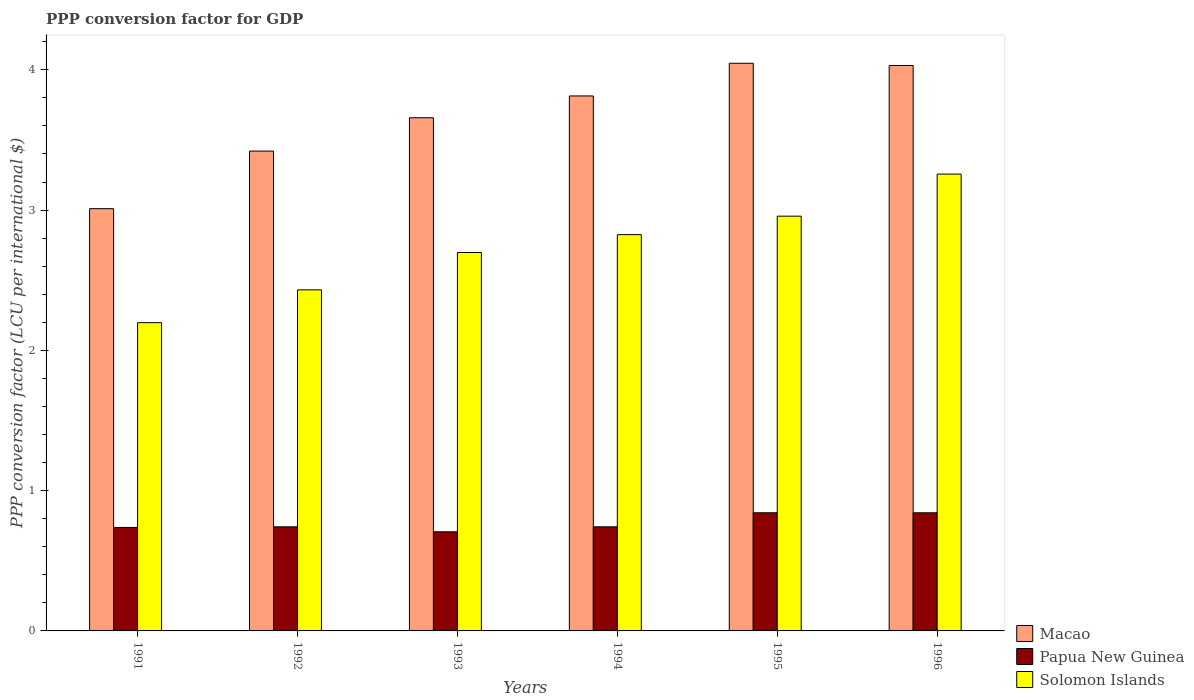How many different coloured bars are there?
Make the answer very short. 3. How many groups of bars are there?
Your answer should be very brief. 6. Are the number of bars per tick equal to the number of legend labels?
Give a very brief answer. Yes. Are the number of bars on each tick of the X-axis equal?
Ensure brevity in your answer.  Yes. How many bars are there on the 5th tick from the left?
Provide a succinct answer. 3. In how many cases, is the number of bars for a given year not equal to the number of legend labels?
Keep it short and to the point. 0. What is the PPP conversion factor for GDP in Macao in 1996?
Offer a very short reply. 4.03. Across all years, what is the maximum PPP conversion factor for GDP in Solomon Islands?
Provide a succinct answer. 3.26. Across all years, what is the minimum PPP conversion factor for GDP in Macao?
Make the answer very short. 3.01. What is the total PPP conversion factor for GDP in Solomon Islands in the graph?
Your answer should be very brief. 16.37. What is the difference between the PPP conversion factor for GDP in Papua New Guinea in 1993 and that in 1995?
Your answer should be compact. -0.14. What is the difference between the PPP conversion factor for GDP in Solomon Islands in 1992 and the PPP conversion factor for GDP in Papua New Guinea in 1996?
Ensure brevity in your answer.  1.59. What is the average PPP conversion factor for GDP in Solomon Islands per year?
Ensure brevity in your answer.  2.73. In the year 1992, what is the difference between the PPP conversion factor for GDP in Solomon Islands and PPP conversion factor for GDP in Papua New Guinea?
Provide a succinct answer. 1.69. What is the ratio of the PPP conversion factor for GDP in Papua New Guinea in 1992 to that in 1994?
Ensure brevity in your answer.  1. Is the PPP conversion factor for GDP in Papua New Guinea in 1995 less than that in 1996?
Your answer should be very brief. No. Is the difference between the PPP conversion factor for GDP in Solomon Islands in 1992 and 1993 greater than the difference between the PPP conversion factor for GDP in Papua New Guinea in 1992 and 1993?
Provide a short and direct response. No. What is the difference between the highest and the second highest PPP conversion factor for GDP in Papua New Guinea?
Offer a terse response. 0. What is the difference between the highest and the lowest PPP conversion factor for GDP in Papua New Guinea?
Your answer should be compact. 0.14. What does the 3rd bar from the left in 1994 represents?
Make the answer very short. Solomon Islands. What does the 2nd bar from the right in 1991 represents?
Give a very brief answer. Papua New Guinea. Is it the case that in every year, the sum of the PPP conversion factor for GDP in Solomon Islands and PPP conversion factor for GDP in Papua New Guinea is greater than the PPP conversion factor for GDP in Macao?
Your response must be concise. No. How many bars are there?
Give a very brief answer. 18. Are all the bars in the graph horizontal?
Your answer should be very brief. No. What is the difference between two consecutive major ticks on the Y-axis?
Keep it short and to the point. 1. Where does the legend appear in the graph?
Ensure brevity in your answer.  Bottom right. How many legend labels are there?
Ensure brevity in your answer.  3. How are the legend labels stacked?
Keep it short and to the point. Vertical. What is the title of the graph?
Ensure brevity in your answer.  PPP conversion factor for GDP. Does "Virgin Islands" appear as one of the legend labels in the graph?
Ensure brevity in your answer.  No. What is the label or title of the X-axis?
Ensure brevity in your answer.  Years. What is the label or title of the Y-axis?
Your response must be concise. PPP conversion factor (LCU per international $). What is the PPP conversion factor (LCU per international $) of Macao in 1991?
Your response must be concise. 3.01. What is the PPP conversion factor (LCU per international $) of Papua New Guinea in 1991?
Your answer should be compact. 0.74. What is the PPP conversion factor (LCU per international $) in Solomon Islands in 1991?
Offer a very short reply. 2.2. What is the PPP conversion factor (LCU per international $) of Macao in 1992?
Give a very brief answer. 3.42. What is the PPP conversion factor (LCU per international $) of Papua New Guinea in 1992?
Your response must be concise. 0.74. What is the PPP conversion factor (LCU per international $) in Solomon Islands in 1992?
Offer a very short reply. 2.43. What is the PPP conversion factor (LCU per international $) of Macao in 1993?
Your response must be concise. 3.66. What is the PPP conversion factor (LCU per international $) of Papua New Guinea in 1993?
Provide a succinct answer. 0.71. What is the PPP conversion factor (LCU per international $) of Solomon Islands in 1993?
Make the answer very short. 2.7. What is the PPP conversion factor (LCU per international $) of Macao in 1994?
Ensure brevity in your answer.  3.81. What is the PPP conversion factor (LCU per international $) in Papua New Guinea in 1994?
Provide a succinct answer. 0.74. What is the PPP conversion factor (LCU per international $) in Solomon Islands in 1994?
Your answer should be very brief. 2.82. What is the PPP conversion factor (LCU per international $) of Macao in 1995?
Keep it short and to the point. 4.05. What is the PPP conversion factor (LCU per international $) of Papua New Guinea in 1995?
Your answer should be very brief. 0.84. What is the PPP conversion factor (LCU per international $) of Solomon Islands in 1995?
Offer a terse response. 2.96. What is the PPP conversion factor (LCU per international $) of Macao in 1996?
Your response must be concise. 4.03. What is the PPP conversion factor (LCU per international $) in Papua New Guinea in 1996?
Ensure brevity in your answer.  0.84. What is the PPP conversion factor (LCU per international $) of Solomon Islands in 1996?
Make the answer very short. 3.26. Across all years, what is the maximum PPP conversion factor (LCU per international $) of Macao?
Your answer should be compact. 4.05. Across all years, what is the maximum PPP conversion factor (LCU per international $) in Papua New Guinea?
Ensure brevity in your answer.  0.84. Across all years, what is the maximum PPP conversion factor (LCU per international $) in Solomon Islands?
Give a very brief answer. 3.26. Across all years, what is the minimum PPP conversion factor (LCU per international $) of Macao?
Ensure brevity in your answer.  3.01. Across all years, what is the minimum PPP conversion factor (LCU per international $) in Papua New Guinea?
Your response must be concise. 0.71. Across all years, what is the minimum PPP conversion factor (LCU per international $) of Solomon Islands?
Give a very brief answer. 2.2. What is the total PPP conversion factor (LCU per international $) in Macao in the graph?
Your response must be concise. 21.98. What is the total PPP conversion factor (LCU per international $) in Papua New Guinea in the graph?
Offer a terse response. 4.61. What is the total PPP conversion factor (LCU per international $) of Solomon Islands in the graph?
Make the answer very short. 16.36. What is the difference between the PPP conversion factor (LCU per international $) in Macao in 1991 and that in 1992?
Offer a very short reply. -0.41. What is the difference between the PPP conversion factor (LCU per international $) in Papua New Guinea in 1991 and that in 1992?
Offer a terse response. -0. What is the difference between the PPP conversion factor (LCU per international $) in Solomon Islands in 1991 and that in 1992?
Provide a short and direct response. -0.23. What is the difference between the PPP conversion factor (LCU per international $) in Macao in 1991 and that in 1993?
Offer a terse response. -0.65. What is the difference between the PPP conversion factor (LCU per international $) in Papua New Guinea in 1991 and that in 1993?
Provide a short and direct response. 0.03. What is the difference between the PPP conversion factor (LCU per international $) in Solomon Islands in 1991 and that in 1993?
Your answer should be very brief. -0.5. What is the difference between the PPP conversion factor (LCU per international $) in Macao in 1991 and that in 1994?
Your answer should be compact. -0.8. What is the difference between the PPP conversion factor (LCU per international $) of Papua New Guinea in 1991 and that in 1994?
Provide a succinct answer. -0. What is the difference between the PPP conversion factor (LCU per international $) of Solomon Islands in 1991 and that in 1994?
Keep it short and to the point. -0.63. What is the difference between the PPP conversion factor (LCU per international $) of Macao in 1991 and that in 1995?
Make the answer very short. -1.04. What is the difference between the PPP conversion factor (LCU per international $) of Papua New Guinea in 1991 and that in 1995?
Your answer should be compact. -0.1. What is the difference between the PPP conversion factor (LCU per international $) of Solomon Islands in 1991 and that in 1995?
Provide a short and direct response. -0.76. What is the difference between the PPP conversion factor (LCU per international $) of Macao in 1991 and that in 1996?
Ensure brevity in your answer.  -1.02. What is the difference between the PPP conversion factor (LCU per international $) of Papua New Guinea in 1991 and that in 1996?
Give a very brief answer. -0.1. What is the difference between the PPP conversion factor (LCU per international $) of Solomon Islands in 1991 and that in 1996?
Make the answer very short. -1.06. What is the difference between the PPP conversion factor (LCU per international $) of Macao in 1992 and that in 1993?
Make the answer very short. -0.24. What is the difference between the PPP conversion factor (LCU per international $) in Papua New Guinea in 1992 and that in 1993?
Offer a terse response. 0.04. What is the difference between the PPP conversion factor (LCU per international $) in Solomon Islands in 1992 and that in 1993?
Your answer should be very brief. -0.27. What is the difference between the PPP conversion factor (LCU per international $) of Macao in 1992 and that in 1994?
Keep it short and to the point. -0.39. What is the difference between the PPP conversion factor (LCU per international $) in Papua New Guinea in 1992 and that in 1994?
Provide a short and direct response. -0. What is the difference between the PPP conversion factor (LCU per international $) in Solomon Islands in 1992 and that in 1994?
Your response must be concise. -0.39. What is the difference between the PPP conversion factor (LCU per international $) of Macao in 1992 and that in 1995?
Give a very brief answer. -0.63. What is the difference between the PPP conversion factor (LCU per international $) of Papua New Guinea in 1992 and that in 1995?
Offer a terse response. -0.1. What is the difference between the PPP conversion factor (LCU per international $) in Solomon Islands in 1992 and that in 1995?
Offer a very short reply. -0.53. What is the difference between the PPP conversion factor (LCU per international $) in Macao in 1992 and that in 1996?
Provide a short and direct response. -0.61. What is the difference between the PPP conversion factor (LCU per international $) of Papua New Guinea in 1992 and that in 1996?
Keep it short and to the point. -0.1. What is the difference between the PPP conversion factor (LCU per international $) of Solomon Islands in 1992 and that in 1996?
Give a very brief answer. -0.83. What is the difference between the PPP conversion factor (LCU per international $) in Macao in 1993 and that in 1994?
Your response must be concise. -0.16. What is the difference between the PPP conversion factor (LCU per international $) of Papua New Guinea in 1993 and that in 1994?
Your answer should be very brief. -0.04. What is the difference between the PPP conversion factor (LCU per international $) of Solomon Islands in 1993 and that in 1994?
Provide a succinct answer. -0.13. What is the difference between the PPP conversion factor (LCU per international $) in Macao in 1993 and that in 1995?
Your answer should be very brief. -0.39. What is the difference between the PPP conversion factor (LCU per international $) in Papua New Guinea in 1993 and that in 1995?
Your answer should be compact. -0.14. What is the difference between the PPP conversion factor (LCU per international $) in Solomon Islands in 1993 and that in 1995?
Your response must be concise. -0.26. What is the difference between the PPP conversion factor (LCU per international $) of Macao in 1993 and that in 1996?
Offer a terse response. -0.37. What is the difference between the PPP conversion factor (LCU per international $) in Papua New Guinea in 1993 and that in 1996?
Give a very brief answer. -0.14. What is the difference between the PPP conversion factor (LCU per international $) in Solomon Islands in 1993 and that in 1996?
Offer a terse response. -0.56. What is the difference between the PPP conversion factor (LCU per international $) in Macao in 1994 and that in 1995?
Your answer should be very brief. -0.23. What is the difference between the PPP conversion factor (LCU per international $) of Papua New Guinea in 1994 and that in 1995?
Provide a short and direct response. -0.1. What is the difference between the PPP conversion factor (LCU per international $) of Solomon Islands in 1994 and that in 1995?
Give a very brief answer. -0.13. What is the difference between the PPP conversion factor (LCU per international $) in Macao in 1994 and that in 1996?
Keep it short and to the point. -0.22. What is the difference between the PPP conversion factor (LCU per international $) in Solomon Islands in 1994 and that in 1996?
Your answer should be very brief. -0.43. What is the difference between the PPP conversion factor (LCU per international $) of Macao in 1995 and that in 1996?
Offer a terse response. 0.02. What is the difference between the PPP conversion factor (LCU per international $) of Papua New Guinea in 1995 and that in 1996?
Provide a short and direct response. 0. What is the difference between the PPP conversion factor (LCU per international $) in Solomon Islands in 1995 and that in 1996?
Provide a succinct answer. -0.3. What is the difference between the PPP conversion factor (LCU per international $) in Macao in 1991 and the PPP conversion factor (LCU per international $) in Papua New Guinea in 1992?
Your answer should be very brief. 2.27. What is the difference between the PPP conversion factor (LCU per international $) in Macao in 1991 and the PPP conversion factor (LCU per international $) in Solomon Islands in 1992?
Provide a succinct answer. 0.58. What is the difference between the PPP conversion factor (LCU per international $) of Papua New Guinea in 1991 and the PPP conversion factor (LCU per international $) of Solomon Islands in 1992?
Give a very brief answer. -1.69. What is the difference between the PPP conversion factor (LCU per international $) in Macao in 1991 and the PPP conversion factor (LCU per international $) in Papua New Guinea in 1993?
Provide a short and direct response. 2.3. What is the difference between the PPP conversion factor (LCU per international $) in Macao in 1991 and the PPP conversion factor (LCU per international $) in Solomon Islands in 1993?
Make the answer very short. 0.31. What is the difference between the PPP conversion factor (LCU per international $) of Papua New Guinea in 1991 and the PPP conversion factor (LCU per international $) of Solomon Islands in 1993?
Offer a terse response. -1.96. What is the difference between the PPP conversion factor (LCU per international $) in Macao in 1991 and the PPP conversion factor (LCU per international $) in Papua New Guinea in 1994?
Give a very brief answer. 2.27. What is the difference between the PPP conversion factor (LCU per international $) of Macao in 1991 and the PPP conversion factor (LCU per international $) of Solomon Islands in 1994?
Ensure brevity in your answer.  0.18. What is the difference between the PPP conversion factor (LCU per international $) of Papua New Guinea in 1991 and the PPP conversion factor (LCU per international $) of Solomon Islands in 1994?
Keep it short and to the point. -2.09. What is the difference between the PPP conversion factor (LCU per international $) of Macao in 1991 and the PPP conversion factor (LCU per international $) of Papua New Guinea in 1995?
Keep it short and to the point. 2.17. What is the difference between the PPP conversion factor (LCU per international $) of Macao in 1991 and the PPP conversion factor (LCU per international $) of Solomon Islands in 1995?
Provide a succinct answer. 0.05. What is the difference between the PPP conversion factor (LCU per international $) in Papua New Guinea in 1991 and the PPP conversion factor (LCU per international $) in Solomon Islands in 1995?
Provide a succinct answer. -2.22. What is the difference between the PPP conversion factor (LCU per international $) of Macao in 1991 and the PPP conversion factor (LCU per international $) of Papua New Guinea in 1996?
Give a very brief answer. 2.17. What is the difference between the PPP conversion factor (LCU per international $) of Macao in 1991 and the PPP conversion factor (LCU per international $) of Solomon Islands in 1996?
Your response must be concise. -0.25. What is the difference between the PPP conversion factor (LCU per international $) of Papua New Guinea in 1991 and the PPP conversion factor (LCU per international $) of Solomon Islands in 1996?
Your answer should be compact. -2.52. What is the difference between the PPP conversion factor (LCU per international $) in Macao in 1992 and the PPP conversion factor (LCU per international $) in Papua New Guinea in 1993?
Offer a very short reply. 2.71. What is the difference between the PPP conversion factor (LCU per international $) in Macao in 1992 and the PPP conversion factor (LCU per international $) in Solomon Islands in 1993?
Ensure brevity in your answer.  0.72. What is the difference between the PPP conversion factor (LCU per international $) in Papua New Guinea in 1992 and the PPP conversion factor (LCU per international $) in Solomon Islands in 1993?
Make the answer very short. -1.96. What is the difference between the PPP conversion factor (LCU per international $) of Macao in 1992 and the PPP conversion factor (LCU per international $) of Papua New Guinea in 1994?
Provide a succinct answer. 2.68. What is the difference between the PPP conversion factor (LCU per international $) in Macao in 1992 and the PPP conversion factor (LCU per international $) in Solomon Islands in 1994?
Your answer should be very brief. 0.6. What is the difference between the PPP conversion factor (LCU per international $) of Papua New Guinea in 1992 and the PPP conversion factor (LCU per international $) of Solomon Islands in 1994?
Provide a short and direct response. -2.08. What is the difference between the PPP conversion factor (LCU per international $) in Macao in 1992 and the PPP conversion factor (LCU per international $) in Papua New Guinea in 1995?
Ensure brevity in your answer.  2.58. What is the difference between the PPP conversion factor (LCU per international $) in Macao in 1992 and the PPP conversion factor (LCU per international $) in Solomon Islands in 1995?
Offer a terse response. 0.46. What is the difference between the PPP conversion factor (LCU per international $) of Papua New Guinea in 1992 and the PPP conversion factor (LCU per international $) of Solomon Islands in 1995?
Your response must be concise. -2.21. What is the difference between the PPP conversion factor (LCU per international $) in Macao in 1992 and the PPP conversion factor (LCU per international $) in Papua New Guinea in 1996?
Provide a succinct answer. 2.58. What is the difference between the PPP conversion factor (LCU per international $) of Macao in 1992 and the PPP conversion factor (LCU per international $) of Solomon Islands in 1996?
Your answer should be very brief. 0.16. What is the difference between the PPP conversion factor (LCU per international $) of Papua New Guinea in 1992 and the PPP conversion factor (LCU per international $) of Solomon Islands in 1996?
Your answer should be compact. -2.51. What is the difference between the PPP conversion factor (LCU per international $) in Macao in 1993 and the PPP conversion factor (LCU per international $) in Papua New Guinea in 1994?
Offer a very short reply. 2.92. What is the difference between the PPP conversion factor (LCU per international $) in Macao in 1993 and the PPP conversion factor (LCU per international $) in Solomon Islands in 1994?
Your answer should be compact. 0.83. What is the difference between the PPP conversion factor (LCU per international $) in Papua New Guinea in 1993 and the PPP conversion factor (LCU per international $) in Solomon Islands in 1994?
Your answer should be compact. -2.12. What is the difference between the PPP conversion factor (LCU per international $) of Macao in 1993 and the PPP conversion factor (LCU per international $) of Papua New Guinea in 1995?
Keep it short and to the point. 2.82. What is the difference between the PPP conversion factor (LCU per international $) of Macao in 1993 and the PPP conversion factor (LCU per international $) of Solomon Islands in 1995?
Give a very brief answer. 0.7. What is the difference between the PPP conversion factor (LCU per international $) of Papua New Guinea in 1993 and the PPP conversion factor (LCU per international $) of Solomon Islands in 1995?
Offer a terse response. -2.25. What is the difference between the PPP conversion factor (LCU per international $) in Macao in 1993 and the PPP conversion factor (LCU per international $) in Papua New Guinea in 1996?
Offer a very short reply. 2.82. What is the difference between the PPP conversion factor (LCU per international $) in Macao in 1993 and the PPP conversion factor (LCU per international $) in Solomon Islands in 1996?
Keep it short and to the point. 0.4. What is the difference between the PPP conversion factor (LCU per international $) in Papua New Guinea in 1993 and the PPP conversion factor (LCU per international $) in Solomon Islands in 1996?
Your response must be concise. -2.55. What is the difference between the PPP conversion factor (LCU per international $) in Macao in 1994 and the PPP conversion factor (LCU per international $) in Papua New Guinea in 1995?
Ensure brevity in your answer.  2.97. What is the difference between the PPP conversion factor (LCU per international $) of Macao in 1994 and the PPP conversion factor (LCU per international $) of Solomon Islands in 1995?
Make the answer very short. 0.86. What is the difference between the PPP conversion factor (LCU per international $) of Papua New Guinea in 1994 and the PPP conversion factor (LCU per international $) of Solomon Islands in 1995?
Your response must be concise. -2.21. What is the difference between the PPP conversion factor (LCU per international $) of Macao in 1994 and the PPP conversion factor (LCU per international $) of Papua New Guinea in 1996?
Your answer should be compact. 2.97. What is the difference between the PPP conversion factor (LCU per international $) in Macao in 1994 and the PPP conversion factor (LCU per international $) in Solomon Islands in 1996?
Your answer should be very brief. 0.56. What is the difference between the PPP conversion factor (LCU per international $) in Papua New Guinea in 1994 and the PPP conversion factor (LCU per international $) in Solomon Islands in 1996?
Offer a very short reply. -2.51. What is the difference between the PPP conversion factor (LCU per international $) in Macao in 1995 and the PPP conversion factor (LCU per international $) in Papua New Guinea in 1996?
Provide a succinct answer. 3.2. What is the difference between the PPP conversion factor (LCU per international $) in Macao in 1995 and the PPP conversion factor (LCU per international $) in Solomon Islands in 1996?
Offer a terse response. 0.79. What is the difference between the PPP conversion factor (LCU per international $) in Papua New Guinea in 1995 and the PPP conversion factor (LCU per international $) in Solomon Islands in 1996?
Your answer should be compact. -2.41. What is the average PPP conversion factor (LCU per international $) of Macao per year?
Offer a terse response. 3.66. What is the average PPP conversion factor (LCU per international $) in Papua New Guinea per year?
Offer a terse response. 0.77. What is the average PPP conversion factor (LCU per international $) of Solomon Islands per year?
Keep it short and to the point. 2.73. In the year 1991, what is the difference between the PPP conversion factor (LCU per international $) of Macao and PPP conversion factor (LCU per international $) of Papua New Guinea?
Offer a very short reply. 2.27. In the year 1991, what is the difference between the PPP conversion factor (LCU per international $) of Macao and PPP conversion factor (LCU per international $) of Solomon Islands?
Offer a very short reply. 0.81. In the year 1991, what is the difference between the PPP conversion factor (LCU per international $) of Papua New Guinea and PPP conversion factor (LCU per international $) of Solomon Islands?
Provide a short and direct response. -1.46. In the year 1992, what is the difference between the PPP conversion factor (LCU per international $) in Macao and PPP conversion factor (LCU per international $) in Papua New Guinea?
Your answer should be very brief. 2.68. In the year 1992, what is the difference between the PPP conversion factor (LCU per international $) in Macao and PPP conversion factor (LCU per international $) in Solomon Islands?
Make the answer very short. 0.99. In the year 1992, what is the difference between the PPP conversion factor (LCU per international $) of Papua New Guinea and PPP conversion factor (LCU per international $) of Solomon Islands?
Offer a terse response. -1.69. In the year 1993, what is the difference between the PPP conversion factor (LCU per international $) in Macao and PPP conversion factor (LCU per international $) in Papua New Guinea?
Keep it short and to the point. 2.95. In the year 1993, what is the difference between the PPP conversion factor (LCU per international $) of Macao and PPP conversion factor (LCU per international $) of Solomon Islands?
Keep it short and to the point. 0.96. In the year 1993, what is the difference between the PPP conversion factor (LCU per international $) of Papua New Guinea and PPP conversion factor (LCU per international $) of Solomon Islands?
Your answer should be compact. -1.99. In the year 1994, what is the difference between the PPP conversion factor (LCU per international $) of Macao and PPP conversion factor (LCU per international $) of Papua New Guinea?
Offer a very short reply. 3.07. In the year 1994, what is the difference between the PPP conversion factor (LCU per international $) of Papua New Guinea and PPP conversion factor (LCU per international $) of Solomon Islands?
Make the answer very short. -2.08. In the year 1995, what is the difference between the PPP conversion factor (LCU per international $) of Macao and PPP conversion factor (LCU per international $) of Papua New Guinea?
Make the answer very short. 3.2. In the year 1995, what is the difference between the PPP conversion factor (LCU per international $) of Macao and PPP conversion factor (LCU per international $) of Solomon Islands?
Your answer should be compact. 1.09. In the year 1995, what is the difference between the PPP conversion factor (LCU per international $) of Papua New Guinea and PPP conversion factor (LCU per international $) of Solomon Islands?
Offer a very short reply. -2.11. In the year 1996, what is the difference between the PPP conversion factor (LCU per international $) of Macao and PPP conversion factor (LCU per international $) of Papua New Guinea?
Provide a succinct answer. 3.19. In the year 1996, what is the difference between the PPP conversion factor (LCU per international $) of Macao and PPP conversion factor (LCU per international $) of Solomon Islands?
Ensure brevity in your answer.  0.77. In the year 1996, what is the difference between the PPP conversion factor (LCU per international $) of Papua New Guinea and PPP conversion factor (LCU per international $) of Solomon Islands?
Ensure brevity in your answer.  -2.41. What is the ratio of the PPP conversion factor (LCU per international $) of Solomon Islands in 1991 to that in 1992?
Ensure brevity in your answer.  0.9. What is the ratio of the PPP conversion factor (LCU per international $) of Macao in 1991 to that in 1993?
Your answer should be very brief. 0.82. What is the ratio of the PPP conversion factor (LCU per international $) in Papua New Guinea in 1991 to that in 1993?
Offer a terse response. 1.04. What is the ratio of the PPP conversion factor (LCU per international $) in Solomon Islands in 1991 to that in 1993?
Provide a succinct answer. 0.81. What is the ratio of the PPP conversion factor (LCU per international $) of Macao in 1991 to that in 1994?
Offer a very short reply. 0.79. What is the ratio of the PPP conversion factor (LCU per international $) in Papua New Guinea in 1991 to that in 1994?
Your response must be concise. 0.99. What is the ratio of the PPP conversion factor (LCU per international $) in Solomon Islands in 1991 to that in 1994?
Offer a very short reply. 0.78. What is the ratio of the PPP conversion factor (LCU per international $) of Macao in 1991 to that in 1995?
Make the answer very short. 0.74. What is the ratio of the PPP conversion factor (LCU per international $) in Papua New Guinea in 1991 to that in 1995?
Provide a succinct answer. 0.88. What is the ratio of the PPP conversion factor (LCU per international $) in Solomon Islands in 1991 to that in 1995?
Provide a succinct answer. 0.74. What is the ratio of the PPP conversion factor (LCU per international $) in Macao in 1991 to that in 1996?
Offer a terse response. 0.75. What is the ratio of the PPP conversion factor (LCU per international $) in Papua New Guinea in 1991 to that in 1996?
Give a very brief answer. 0.88. What is the ratio of the PPP conversion factor (LCU per international $) of Solomon Islands in 1991 to that in 1996?
Offer a very short reply. 0.67. What is the ratio of the PPP conversion factor (LCU per international $) in Macao in 1992 to that in 1993?
Your answer should be compact. 0.94. What is the ratio of the PPP conversion factor (LCU per international $) in Papua New Guinea in 1992 to that in 1993?
Offer a very short reply. 1.05. What is the ratio of the PPP conversion factor (LCU per international $) of Solomon Islands in 1992 to that in 1993?
Offer a very short reply. 0.9. What is the ratio of the PPP conversion factor (LCU per international $) in Macao in 1992 to that in 1994?
Your response must be concise. 0.9. What is the ratio of the PPP conversion factor (LCU per international $) in Solomon Islands in 1992 to that in 1994?
Your answer should be compact. 0.86. What is the ratio of the PPP conversion factor (LCU per international $) of Macao in 1992 to that in 1995?
Provide a short and direct response. 0.85. What is the ratio of the PPP conversion factor (LCU per international $) of Papua New Guinea in 1992 to that in 1995?
Your answer should be compact. 0.88. What is the ratio of the PPP conversion factor (LCU per international $) of Solomon Islands in 1992 to that in 1995?
Your answer should be compact. 0.82. What is the ratio of the PPP conversion factor (LCU per international $) of Macao in 1992 to that in 1996?
Give a very brief answer. 0.85. What is the ratio of the PPP conversion factor (LCU per international $) of Papua New Guinea in 1992 to that in 1996?
Ensure brevity in your answer.  0.88. What is the ratio of the PPP conversion factor (LCU per international $) of Solomon Islands in 1992 to that in 1996?
Provide a short and direct response. 0.75. What is the ratio of the PPP conversion factor (LCU per international $) of Macao in 1993 to that in 1994?
Provide a succinct answer. 0.96. What is the ratio of the PPP conversion factor (LCU per international $) in Papua New Guinea in 1993 to that in 1994?
Provide a succinct answer. 0.95. What is the ratio of the PPP conversion factor (LCU per international $) of Solomon Islands in 1993 to that in 1994?
Your answer should be compact. 0.95. What is the ratio of the PPP conversion factor (LCU per international $) in Macao in 1993 to that in 1995?
Keep it short and to the point. 0.9. What is the ratio of the PPP conversion factor (LCU per international $) of Papua New Guinea in 1993 to that in 1995?
Your answer should be very brief. 0.84. What is the ratio of the PPP conversion factor (LCU per international $) in Solomon Islands in 1993 to that in 1995?
Keep it short and to the point. 0.91. What is the ratio of the PPP conversion factor (LCU per international $) of Macao in 1993 to that in 1996?
Your answer should be compact. 0.91. What is the ratio of the PPP conversion factor (LCU per international $) of Papua New Guinea in 1993 to that in 1996?
Your answer should be very brief. 0.84. What is the ratio of the PPP conversion factor (LCU per international $) in Solomon Islands in 1993 to that in 1996?
Offer a very short reply. 0.83. What is the ratio of the PPP conversion factor (LCU per international $) of Macao in 1994 to that in 1995?
Your response must be concise. 0.94. What is the ratio of the PPP conversion factor (LCU per international $) in Papua New Guinea in 1994 to that in 1995?
Offer a terse response. 0.88. What is the ratio of the PPP conversion factor (LCU per international $) of Solomon Islands in 1994 to that in 1995?
Make the answer very short. 0.96. What is the ratio of the PPP conversion factor (LCU per international $) of Macao in 1994 to that in 1996?
Your response must be concise. 0.95. What is the ratio of the PPP conversion factor (LCU per international $) in Papua New Guinea in 1994 to that in 1996?
Your answer should be very brief. 0.88. What is the ratio of the PPP conversion factor (LCU per international $) of Solomon Islands in 1994 to that in 1996?
Provide a succinct answer. 0.87. What is the ratio of the PPP conversion factor (LCU per international $) of Macao in 1995 to that in 1996?
Give a very brief answer. 1. What is the ratio of the PPP conversion factor (LCU per international $) in Papua New Guinea in 1995 to that in 1996?
Offer a very short reply. 1. What is the ratio of the PPP conversion factor (LCU per international $) in Solomon Islands in 1995 to that in 1996?
Offer a terse response. 0.91. What is the difference between the highest and the second highest PPP conversion factor (LCU per international $) in Macao?
Offer a very short reply. 0.02. What is the difference between the highest and the second highest PPP conversion factor (LCU per international $) of Solomon Islands?
Give a very brief answer. 0.3. What is the difference between the highest and the lowest PPP conversion factor (LCU per international $) of Macao?
Your answer should be compact. 1.04. What is the difference between the highest and the lowest PPP conversion factor (LCU per international $) in Papua New Guinea?
Keep it short and to the point. 0.14. What is the difference between the highest and the lowest PPP conversion factor (LCU per international $) in Solomon Islands?
Offer a very short reply. 1.06. 